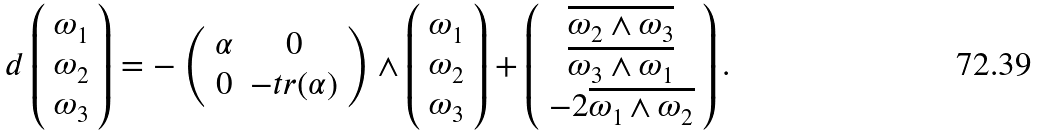<formula> <loc_0><loc_0><loc_500><loc_500>d \left ( \begin{array} { c } \omega _ { 1 } \\ \omega _ { 2 } \\ \omega _ { 3 } \end{array} \right ) = - \left ( \begin{array} { c c } \alpha & 0 \\ 0 & - t r ( \alpha ) \\ \end{array} \right ) \wedge \left ( \begin{array} { c } \omega _ { 1 } \\ \omega _ { 2 } \\ \omega _ { 3 } \end{array} \right ) + \left ( \begin{array} { c } \overline { \omega _ { 2 } \wedge \omega _ { 3 } } \\ \overline { \omega _ { 3 } \wedge \omega _ { 1 } } \\ - 2 \overline { \omega _ { 1 } \wedge \omega _ { 2 } } \end{array} \right ) .</formula> 